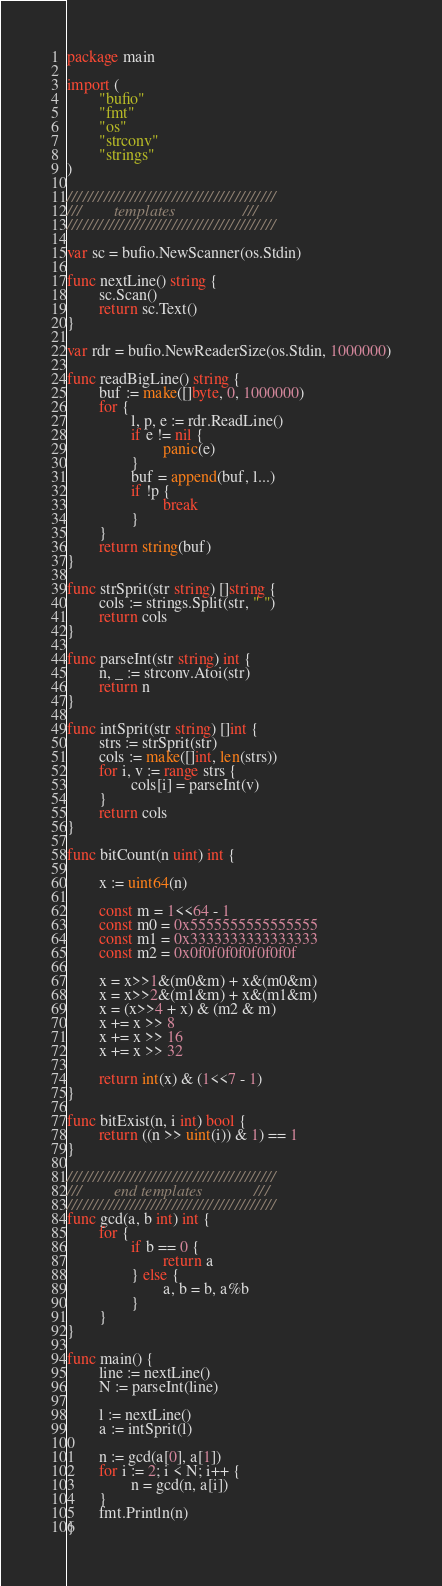<code> <loc_0><loc_0><loc_500><loc_500><_Go_>package main

import (
        "bufio"
        "fmt"
        "os"
        "strconv"
        "strings"
)

////////////////////////////////////////
///        templates                 ///
////////////////////////////////////////

var sc = bufio.NewScanner(os.Stdin)

func nextLine() string {
        sc.Scan()
        return sc.Text()
}

var rdr = bufio.NewReaderSize(os.Stdin, 1000000)

func readBigLine() string {
        buf := make([]byte, 0, 1000000)
        for {
                l, p, e := rdr.ReadLine()
                if e != nil {
                        panic(e)
                }
                buf = append(buf, l...)
                if !p {
                        break
                }
        }
        return string(buf)
}

func strSprit(str string) []string {
        cols := strings.Split(str, " ")
        return cols
}

func parseInt(str string) int {
        n, _ := strconv.Atoi(str)
        return n
}

func intSprit(str string) []int {
        strs := strSprit(str)
        cols := make([]int, len(strs))
        for i, v := range strs {
                cols[i] = parseInt(v)
        }
        return cols
}

func bitCount(n uint) int {

        x := uint64(n)

        const m = 1<<64 - 1
        const m0 = 0x5555555555555555
        const m1 = 0x3333333333333333
        const m2 = 0x0f0f0f0f0f0f0f0f

        x = x>>1&(m0&m) + x&(m0&m)
        x = x>>2&(m1&m) + x&(m1&m)
        x = (x>>4 + x) & (m2 & m)
        x += x >> 8
        x += x >> 16
        x += x >> 32

        return int(x) & (1<<7 - 1)
}

func bitExist(n, i int) bool {
        return ((n >> uint(i)) & 1) == 1
}

////////////////////////////////////////
///        end templates             ///
////////////////////////////////////////
func gcd(a, b int) int {
        for {
                if b == 0 {
                        return a
                } else {
                        a, b = b, a%b
                }
        }
}

func main() {
        line := nextLine()
        N := parseInt(line)

        l := nextLine()
        a := intSprit(l)

        n := gcd(a[0], a[1])
        for i := 2; i < N; i++ {
                n = gcd(n, a[i])
        }
        fmt.Println(n)
}</code> 